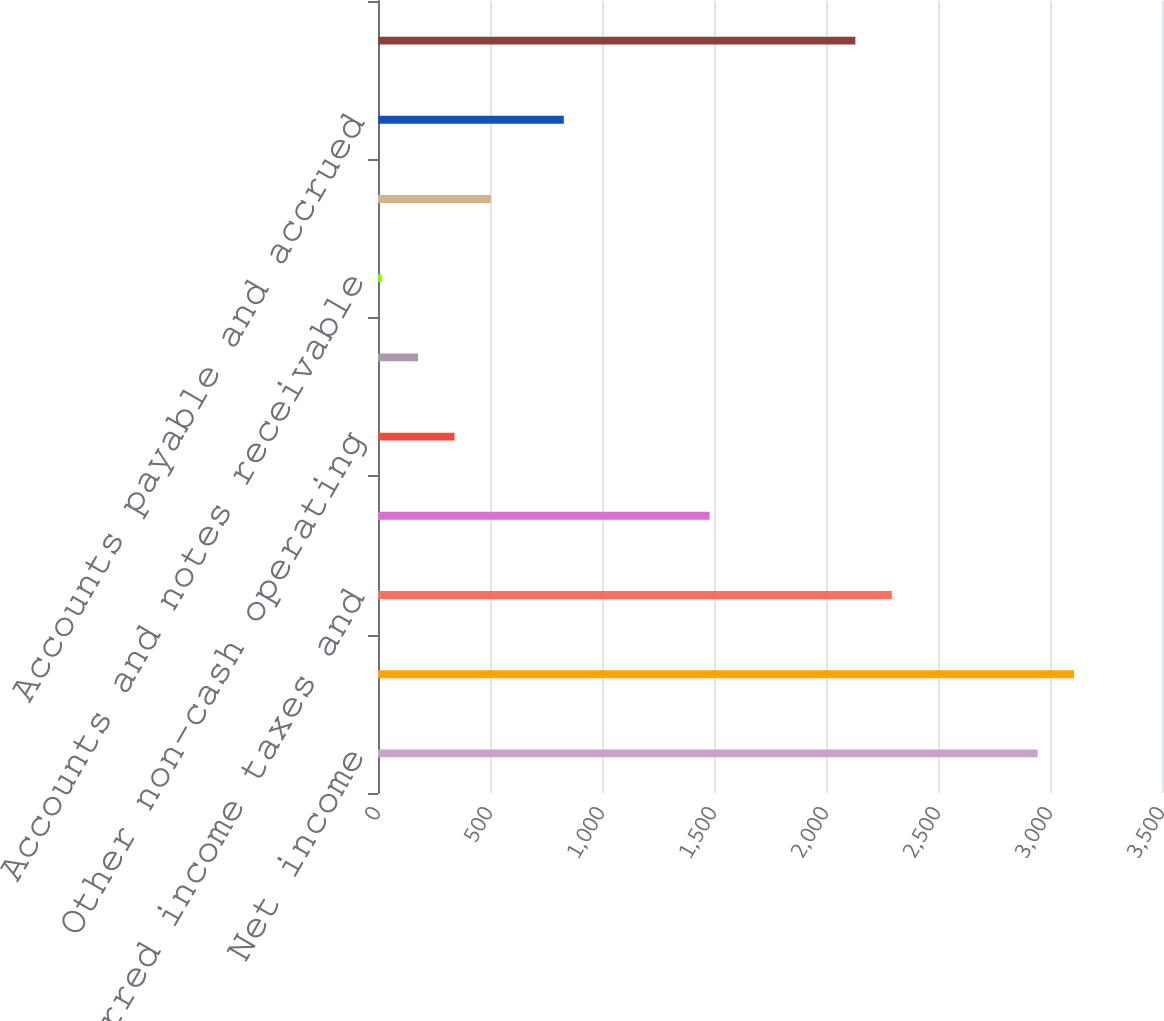Convert chart. <chart><loc_0><loc_0><loc_500><loc_500><bar_chart><fcel>Net income<fcel>Depreciation and amortization<fcel>Deferred income taxes and<fcel>Bad debt expense<fcel>Other non-cash operating<fcel>Postretirement benefits<fcel>Accounts and notes receivable<fcel>Inventories<fcel>Accounts payable and accrued<fcel>Other current and non-current<nl><fcel>2944.6<fcel>3107.3<fcel>2293.8<fcel>1480.3<fcel>341.4<fcel>178.7<fcel>16<fcel>504.1<fcel>829.5<fcel>2131.1<nl></chart> 